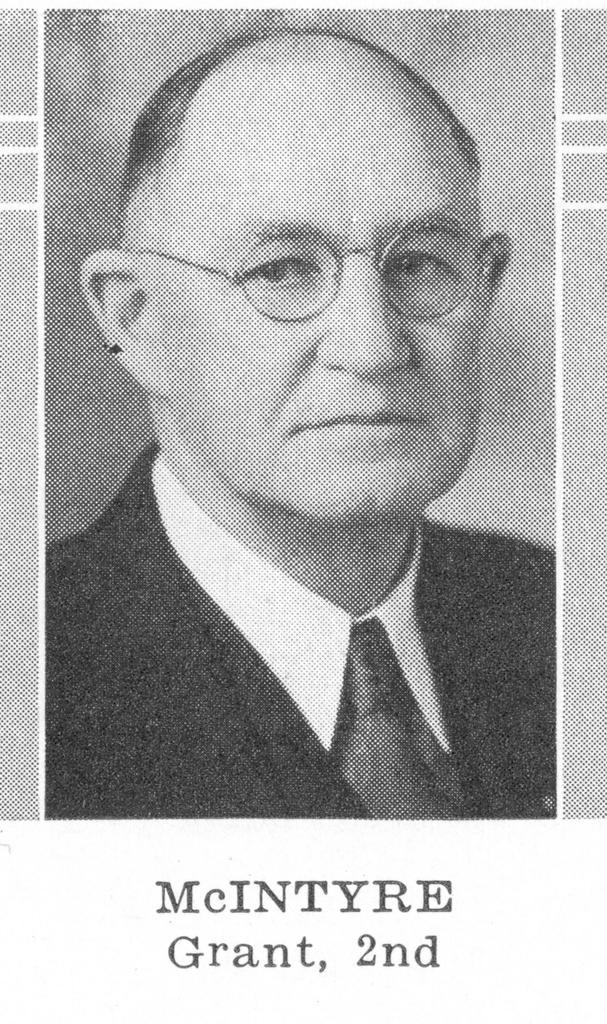What is the color scheme of the image? The image is black and white. What can be seen in the photo within the image? There is a photo of a person with specs in the image. Is there any text present in the image? Yes, there is text written at the bottom of the image. What type of linen is being used as a desk cover in the image? There is no desk or linen present in the image; it features a photo of a person with specs and text at the bottom. 